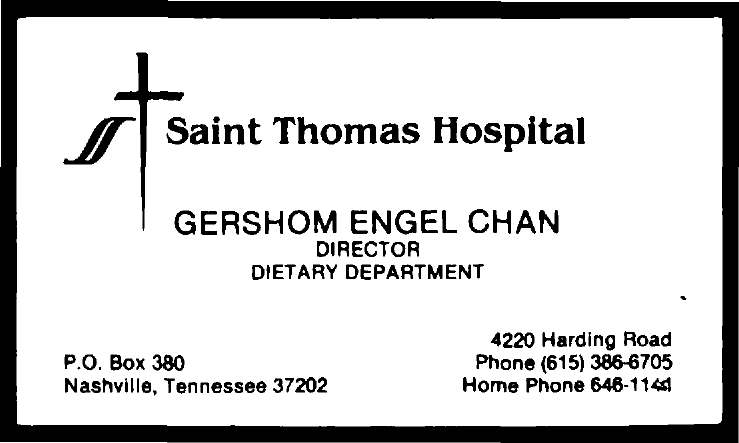What is name of director ?
Make the answer very short. Gershom Engel Chan. What is name of department ?
Provide a short and direct response. Dietary department. What is name of hospital?
Your answer should be compact. Saint Thomas Hospital. 